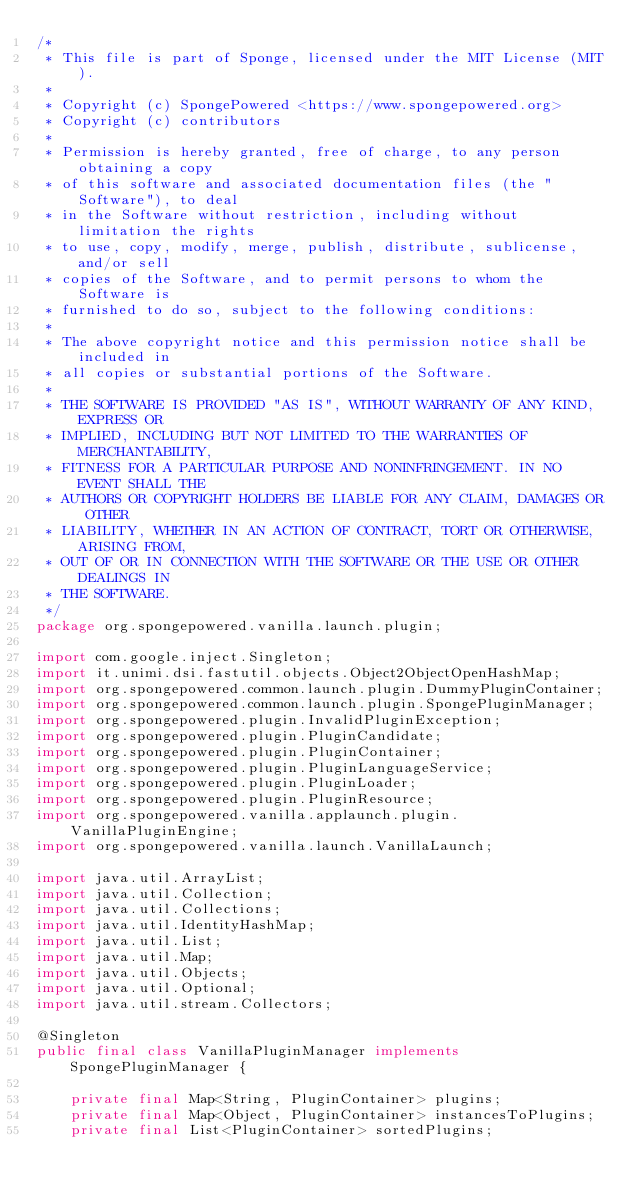Convert code to text. <code><loc_0><loc_0><loc_500><loc_500><_Java_>/*
 * This file is part of Sponge, licensed under the MIT License (MIT).
 *
 * Copyright (c) SpongePowered <https://www.spongepowered.org>
 * Copyright (c) contributors
 *
 * Permission is hereby granted, free of charge, to any person obtaining a copy
 * of this software and associated documentation files (the "Software"), to deal
 * in the Software without restriction, including without limitation the rights
 * to use, copy, modify, merge, publish, distribute, sublicense, and/or sell
 * copies of the Software, and to permit persons to whom the Software is
 * furnished to do so, subject to the following conditions:
 *
 * The above copyright notice and this permission notice shall be included in
 * all copies or substantial portions of the Software.
 *
 * THE SOFTWARE IS PROVIDED "AS IS", WITHOUT WARRANTY OF ANY KIND, EXPRESS OR
 * IMPLIED, INCLUDING BUT NOT LIMITED TO THE WARRANTIES OF MERCHANTABILITY,
 * FITNESS FOR A PARTICULAR PURPOSE AND NONINFRINGEMENT. IN NO EVENT SHALL THE
 * AUTHORS OR COPYRIGHT HOLDERS BE LIABLE FOR ANY CLAIM, DAMAGES OR OTHER
 * LIABILITY, WHETHER IN AN ACTION OF CONTRACT, TORT OR OTHERWISE, ARISING FROM,
 * OUT OF OR IN CONNECTION WITH THE SOFTWARE OR THE USE OR OTHER DEALINGS IN
 * THE SOFTWARE.
 */
package org.spongepowered.vanilla.launch.plugin;

import com.google.inject.Singleton;
import it.unimi.dsi.fastutil.objects.Object2ObjectOpenHashMap;
import org.spongepowered.common.launch.plugin.DummyPluginContainer;
import org.spongepowered.common.launch.plugin.SpongePluginManager;
import org.spongepowered.plugin.InvalidPluginException;
import org.spongepowered.plugin.PluginCandidate;
import org.spongepowered.plugin.PluginContainer;
import org.spongepowered.plugin.PluginLanguageService;
import org.spongepowered.plugin.PluginLoader;
import org.spongepowered.plugin.PluginResource;
import org.spongepowered.vanilla.applaunch.plugin.VanillaPluginEngine;
import org.spongepowered.vanilla.launch.VanillaLaunch;

import java.util.ArrayList;
import java.util.Collection;
import java.util.Collections;
import java.util.IdentityHashMap;
import java.util.List;
import java.util.Map;
import java.util.Objects;
import java.util.Optional;
import java.util.stream.Collectors;

@Singleton
public final class VanillaPluginManager implements SpongePluginManager {

    private final Map<String, PluginContainer> plugins;
    private final Map<Object, PluginContainer> instancesToPlugins;
    private final List<PluginContainer> sortedPlugins;
</code> 